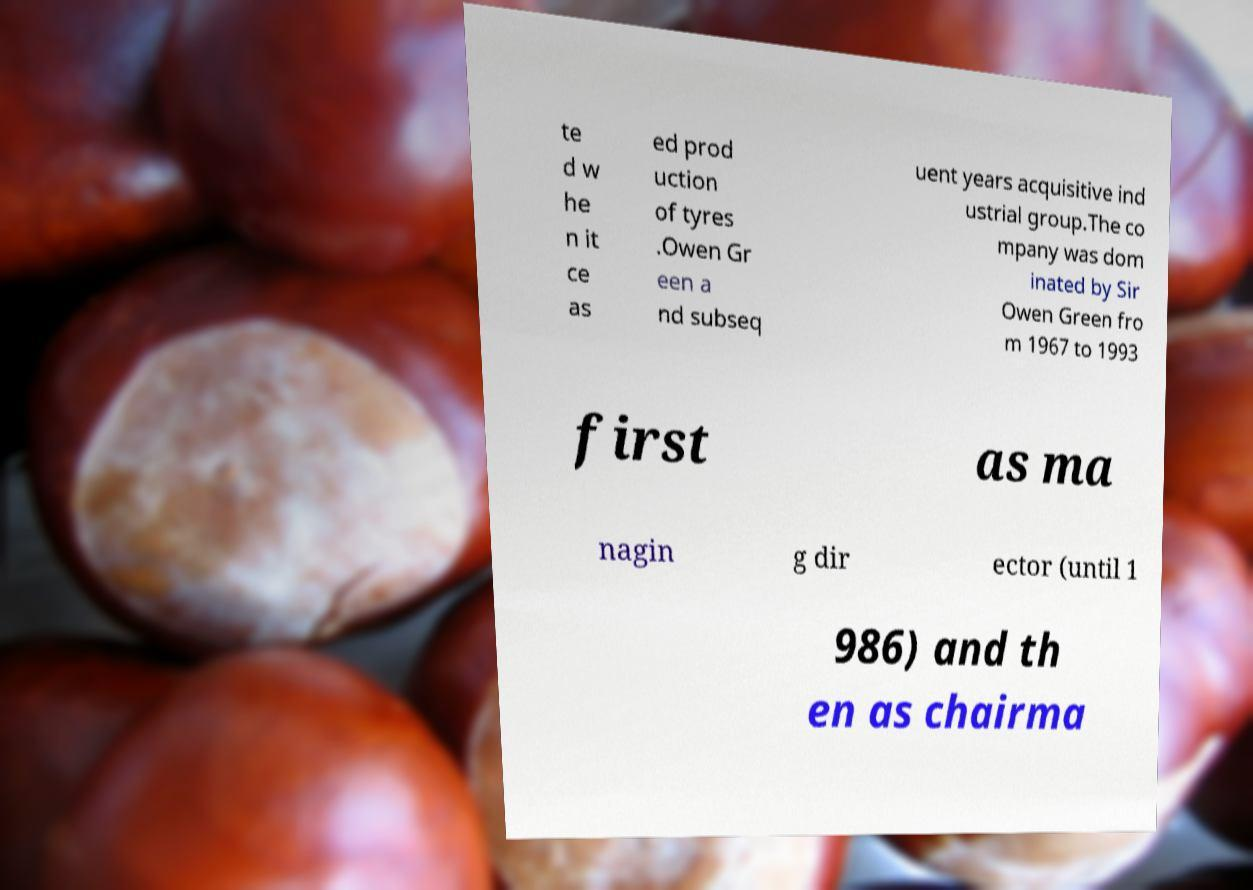Can you read and provide the text displayed in the image?This photo seems to have some interesting text. Can you extract and type it out for me? te d w he n it ce as ed prod uction of tyres .Owen Gr een a nd subseq uent years acquisitive ind ustrial group.The co mpany was dom inated by Sir Owen Green fro m 1967 to 1993 first as ma nagin g dir ector (until 1 986) and th en as chairma 